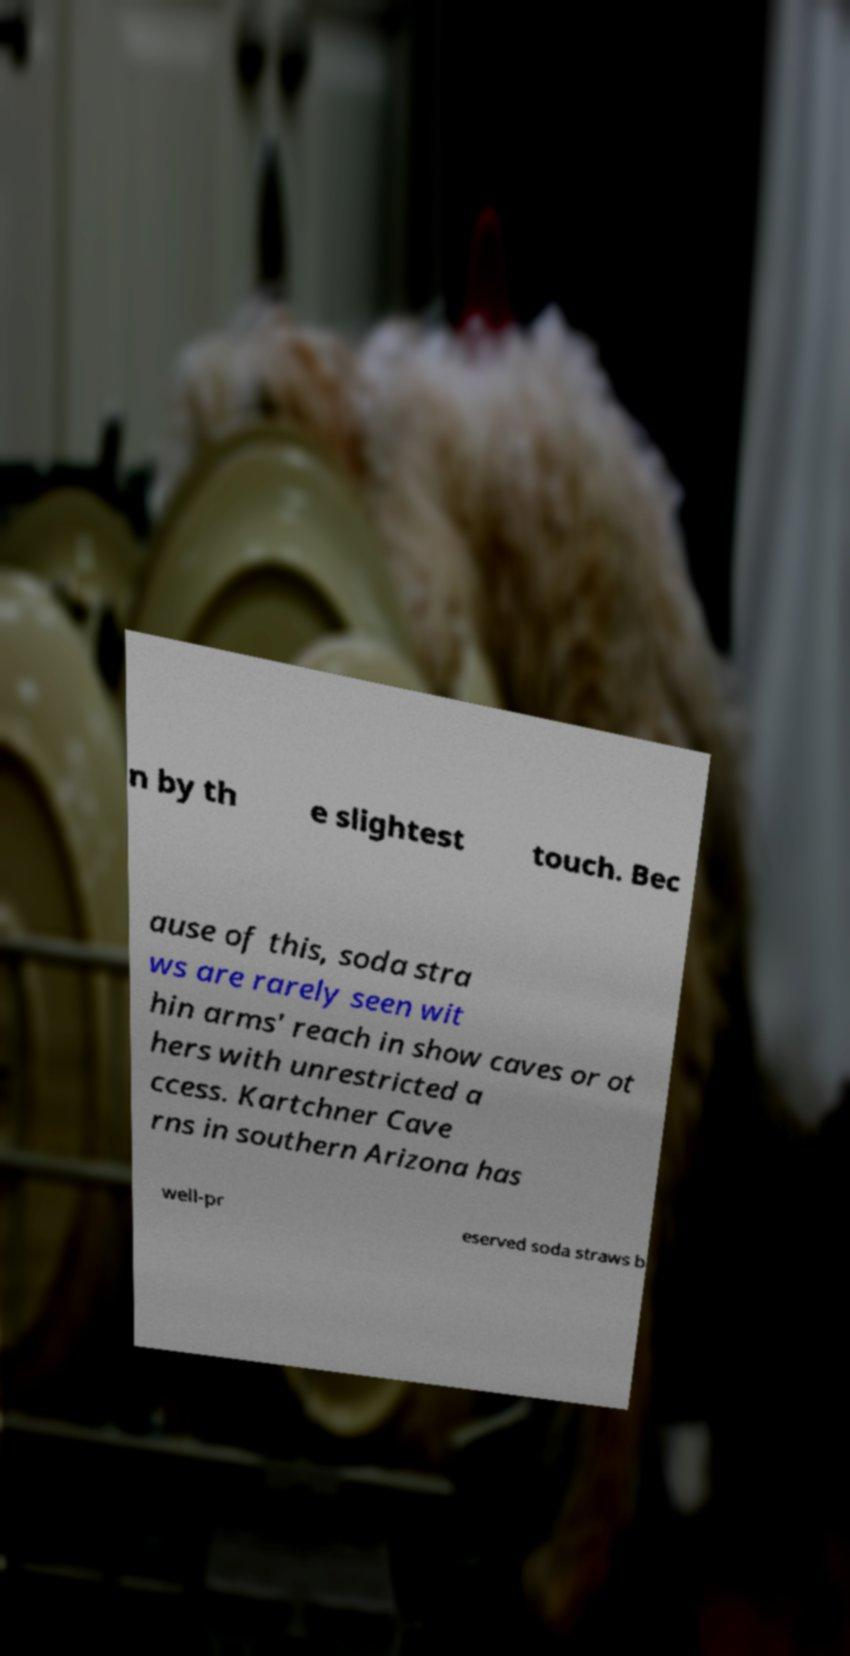For documentation purposes, I need the text within this image transcribed. Could you provide that? n by th e slightest touch. Bec ause of this, soda stra ws are rarely seen wit hin arms' reach in show caves or ot hers with unrestricted a ccess. Kartchner Cave rns in southern Arizona has well-pr eserved soda straws b 